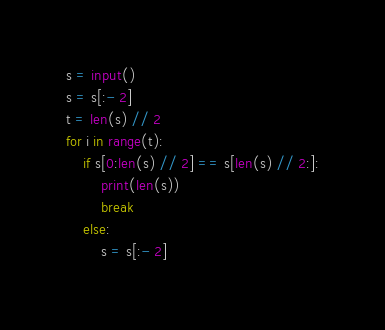Convert code to text. <code><loc_0><loc_0><loc_500><loc_500><_Python_>s = input()
s = s[:- 2]
t = len(s) // 2
for i in range(t):
    if s[0:len(s) // 2] == s[len(s) // 2:]:
        print(len(s))
        break
    else:
        s = s[:- 2]</code> 